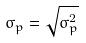<formula> <loc_0><loc_0><loc_500><loc_500>\sigma _ { p } = \sqrt { \sigma _ { p } ^ { 2 } }</formula> 